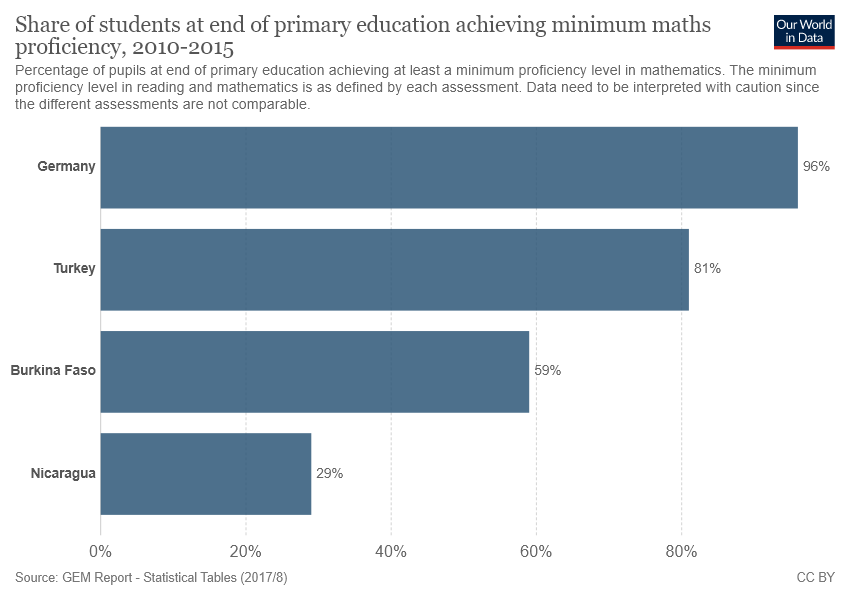Outline some significant characteristics in this image. The graph uses one to five colors, depending on the context. The sum of the smallest two bars is not greater than the value of the largest bar. 